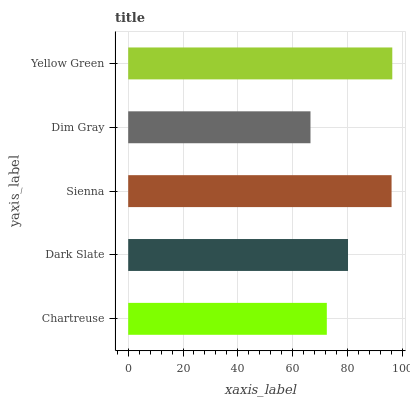Is Dim Gray the minimum?
Answer yes or no. Yes. Is Yellow Green the maximum?
Answer yes or no. Yes. Is Dark Slate the minimum?
Answer yes or no. No. Is Dark Slate the maximum?
Answer yes or no. No. Is Dark Slate greater than Chartreuse?
Answer yes or no. Yes. Is Chartreuse less than Dark Slate?
Answer yes or no. Yes. Is Chartreuse greater than Dark Slate?
Answer yes or no. No. Is Dark Slate less than Chartreuse?
Answer yes or no. No. Is Dark Slate the high median?
Answer yes or no. Yes. Is Dark Slate the low median?
Answer yes or no. Yes. Is Sienna the high median?
Answer yes or no. No. Is Yellow Green the low median?
Answer yes or no. No. 